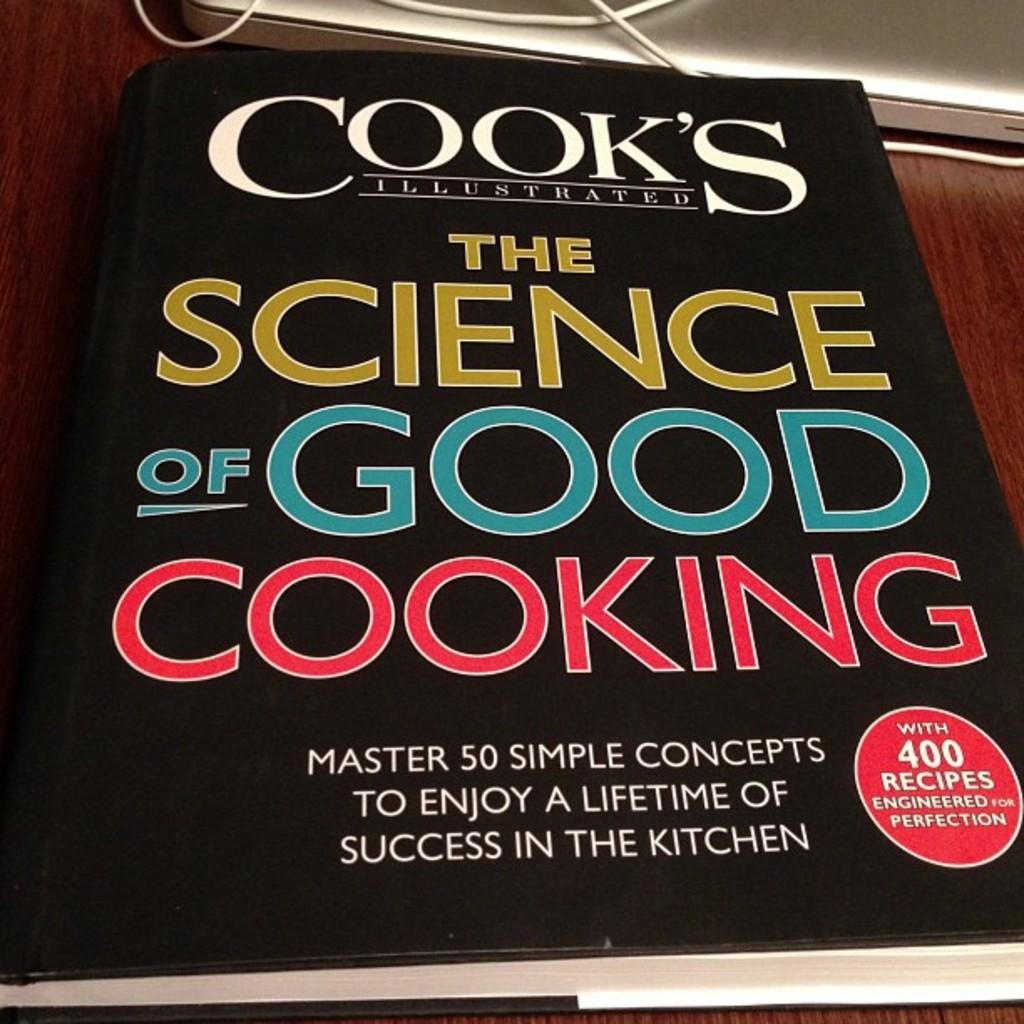Is a cooking book?
Provide a short and direct response. Yes. 